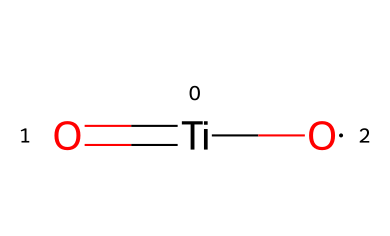What is the main element in this structure? The structure presented shows titanium (Ti) as the central atom bonded to oxygen atoms. The presence of these elements is distinctive and indicates that titanium is the main component of this chemical.
Answer: titanium How many oxygen atoms are present in this molecular composition? Looking at the SMILES representation, there are two oxygen atoms indicated by the two 'O' symbols in the structure. Therefore, the count of oxygen atoms is two.
Answer: two What is the valency of titanium in this compound? Titanium typically has a valency of four in compounds, which is evident as it forms bonds with two oxygen atoms and participates in a double bond with another oxygen in this structure.
Answer: four What type of bonding is present in between titanium and the oxygen atoms? The bonding between titanium and the oxygen atoms includes both a double bond (between titanium and one oxygen) and single bonds (with the second oxygen). This indicates a mix of bonding types.
Answer: double and single bonds What is the overall charge of the titanium dioxide nanoparticle? In its common oxidation state, titanium dioxide is neutral, meaning there is no overall charge in the nanoparticle form represented here.
Answer: neutral How does titanium dioxide behave in water? Titanium dioxide is hydrophobic and does not dissolve well in water, implying it tends to remain as particles when introduced into an aqueous solution.
Answer: hydrophobic Why is titanium dioxide used in sunscreens? Titanium dioxide acts as a physical UV filter, reflecting and scattering ultraviolet light, which is crucial for protecting the skin in sunscreen formulations.
Answer: UV filter 